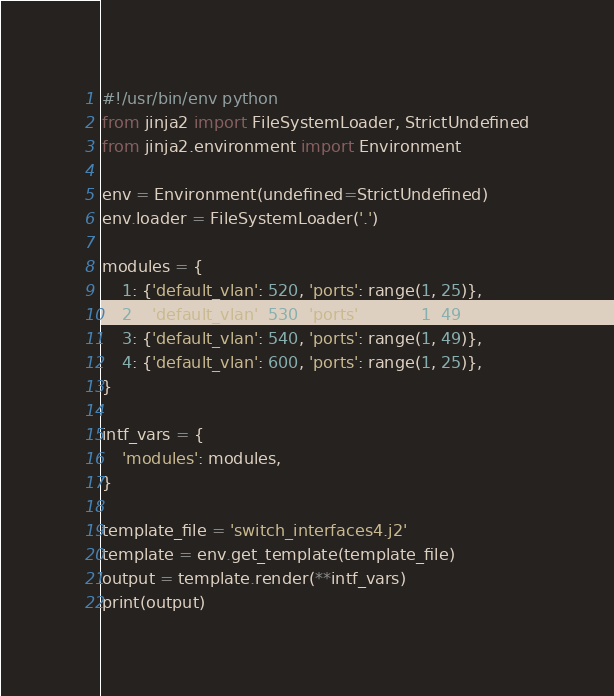Convert code to text. <code><loc_0><loc_0><loc_500><loc_500><_Python_>#!/usr/bin/env python
from jinja2 import FileSystemLoader, StrictUndefined
from jinja2.environment import Environment

env = Environment(undefined=StrictUndefined)
env.loader = FileSystemLoader('.')

modules = {
    1: {'default_vlan': 520, 'ports': range(1, 25)},
    2: {'default_vlan': 530, 'ports': range(1, 49)},
    3: {'default_vlan': 540, 'ports': range(1, 49)},
    4: {'default_vlan': 600, 'ports': range(1, 25)},
}

intf_vars = {
    'modules': modules,
}

template_file = 'switch_interfaces4.j2'
template = env.get_template(template_file)
output = template.render(**intf_vars)
print(output)

</code> 